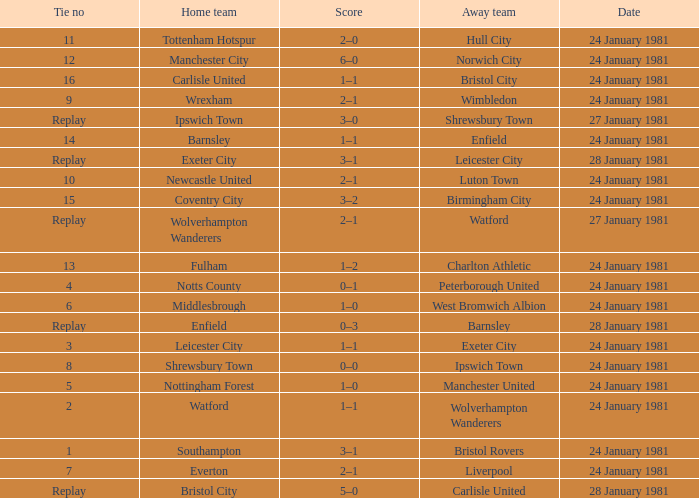What is the score when the tie is 8? 0–0. 